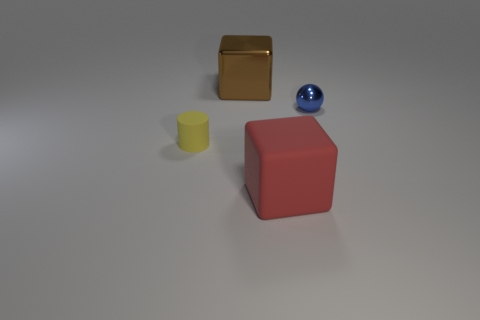What number of other balls are the same color as the shiny ball?
Provide a succinct answer. 0. How many things are either rubber things on the right side of the yellow thing or big objects that are in front of the blue sphere?
Your answer should be very brief. 1. Is the number of tiny blue objects that are to the right of the small metallic ball less than the number of large blue rubber spheres?
Provide a short and direct response. No. Are there any other things that have the same size as the brown shiny object?
Your answer should be compact. Yes. What is the color of the cylinder?
Your answer should be very brief. Yellow. Is the size of the blue shiny sphere the same as the yellow cylinder?
Keep it short and to the point. Yes. How many things are large green rubber blocks or large things?
Make the answer very short. 2. Are there an equal number of large metal cubes that are right of the big brown thing and gray rubber cylinders?
Give a very brief answer. Yes. Are there any matte objects left of the big cube behind the tiny blue sphere behind the matte block?
Keep it short and to the point. Yes. There is a cylinder that is the same material as the red cube; what color is it?
Ensure brevity in your answer.  Yellow. 